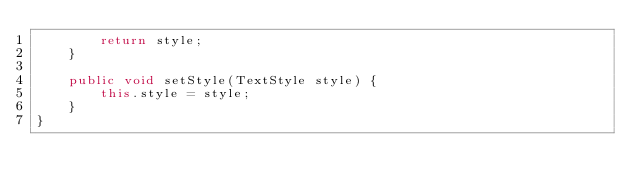Convert code to text. <code><loc_0><loc_0><loc_500><loc_500><_Java_>        return style;
    }

    public void setStyle(TextStyle style) {
        this.style = style;
    }
}
</code> 